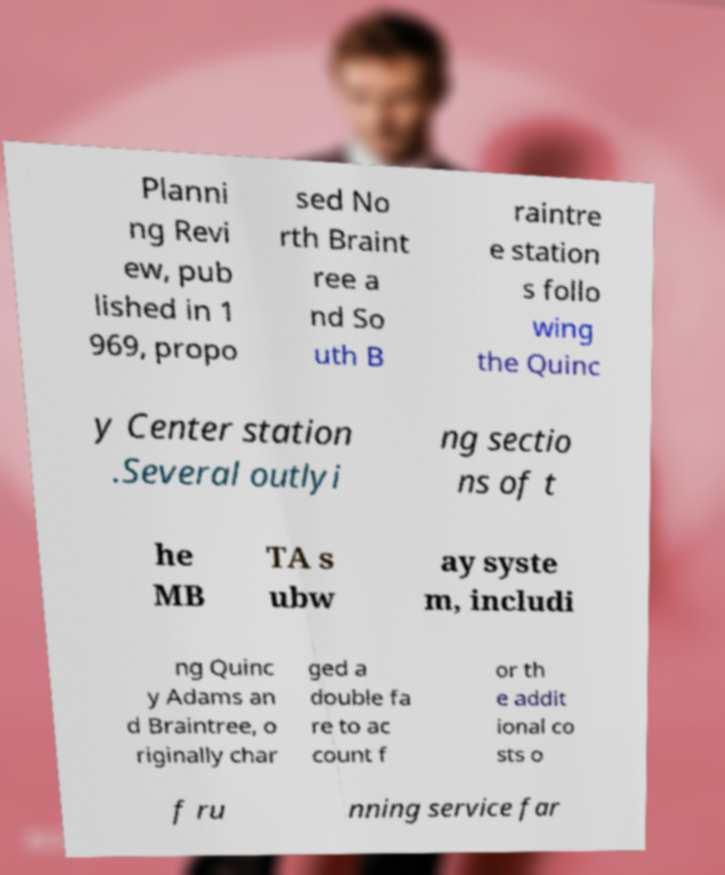Please read and relay the text visible in this image. What does it say? Planni ng Revi ew, pub lished in 1 969, propo sed No rth Braint ree a nd So uth B raintre e station s follo wing the Quinc y Center station .Several outlyi ng sectio ns of t he MB TA s ubw ay syste m, includi ng Quinc y Adams an d Braintree, o riginally char ged a double fa re to ac count f or th e addit ional co sts o f ru nning service far 